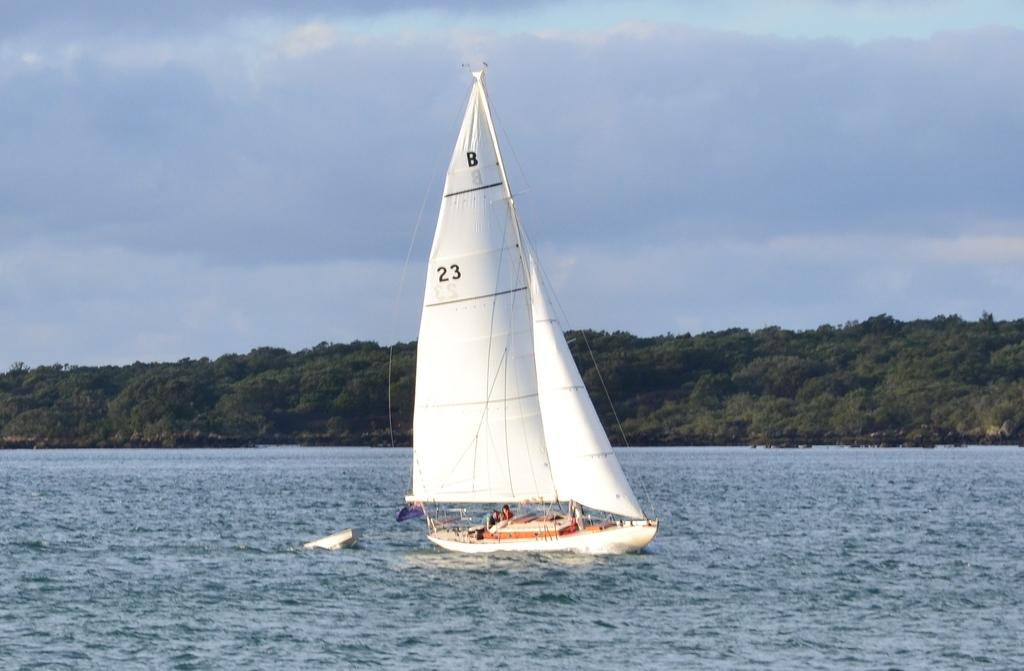What type of vehicle is in the image? There is a white color ship in the image. Where is the ship located? The ship is on the water. What can be seen in the background of the image? There are trees in the background of the image. How would you describe the sky in the image? The sky is cloudy in the image. What type of texture can be seen on the judge's robe in the image? There is no judge or robe present in the image; it features a white color ship on the water with trees in the background and a cloudy sky. 